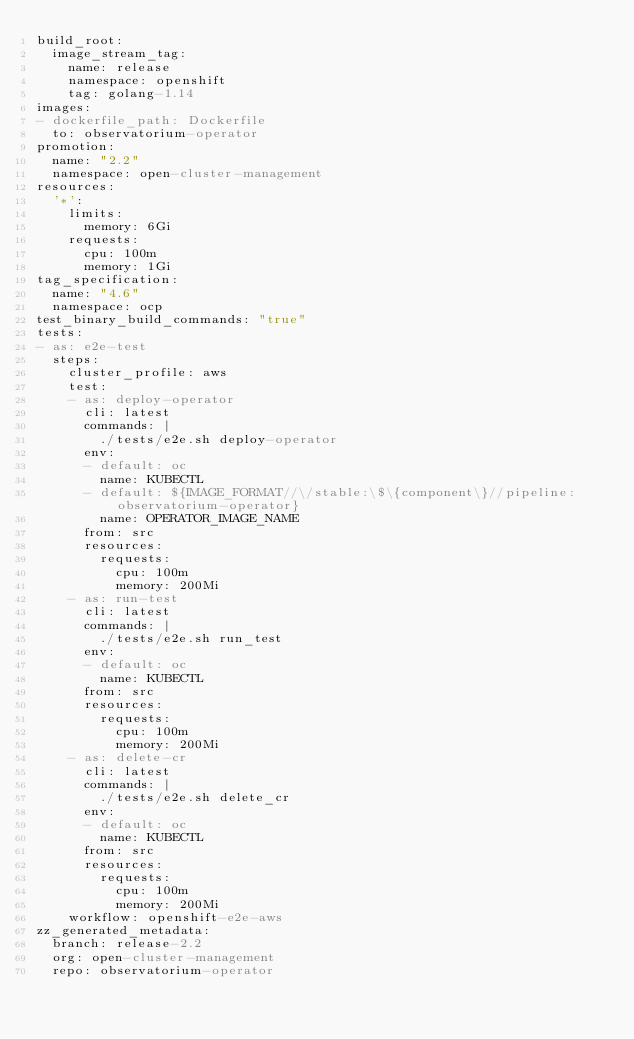<code> <loc_0><loc_0><loc_500><loc_500><_YAML_>build_root:
  image_stream_tag:
    name: release
    namespace: openshift
    tag: golang-1.14
images:
- dockerfile_path: Dockerfile
  to: observatorium-operator
promotion:
  name: "2.2"
  namespace: open-cluster-management
resources:
  '*':
    limits:
      memory: 6Gi
    requests:
      cpu: 100m
      memory: 1Gi
tag_specification:
  name: "4.6"
  namespace: ocp
test_binary_build_commands: "true"
tests:
- as: e2e-test
  steps:
    cluster_profile: aws
    test:
    - as: deploy-operator
      cli: latest
      commands: |
        ./tests/e2e.sh deploy-operator
      env:
      - default: oc
        name: KUBECTL
      - default: ${IMAGE_FORMAT//\/stable:\$\{component\}//pipeline:observatorium-operator}
        name: OPERATOR_IMAGE_NAME
      from: src
      resources:
        requests:
          cpu: 100m
          memory: 200Mi
    - as: run-test
      cli: latest
      commands: |
        ./tests/e2e.sh run_test
      env:
      - default: oc
        name: KUBECTL
      from: src
      resources:
        requests:
          cpu: 100m
          memory: 200Mi
    - as: delete-cr
      cli: latest
      commands: |
        ./tests/e2e.sh delete_cr
      env:
      - default: oc
        name: KUBECTL
      from: src
      resources:
        requests:
          cpu: 100m
          memory: 200Mi
    workflow: openshift-e2e-aws
zz_generated_metadata:
  branch: release-2.2
  org: open-cluster-management
  repo: observatorium-operator
</code> 